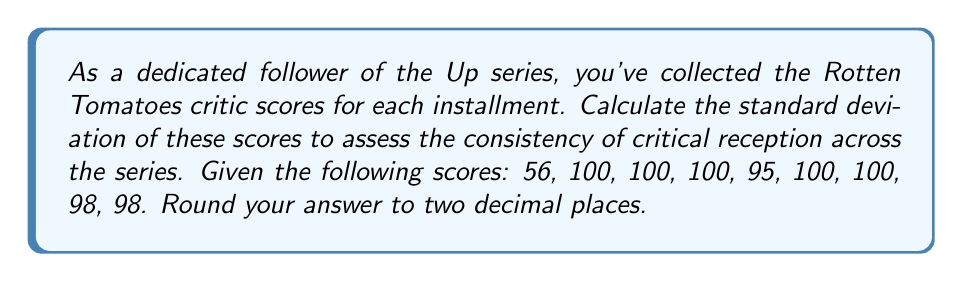Show me your answer to this math problem. To calculate the standard deviation, we'll follow these steps:

1. Calculate the mean ($\mu$) of the scores:
   $$\mu = \frac{56 + 100 + 100 + 100 + 95 + 100 + 100 + 98 + 98}{9} = 94.11$$

2. Calculate the squared differences from the mean:
   $$(56 - 94.11)^2 = 1454.37$$
   $$(100 - 94.11)^2 = 34.61$$
   $$(95 - 94.11)^2 = 0.79$$
   $$(98 - 94.11)^2 = 15.13$$

3. Sum the squared differences:
   $$1454.37 + (34.61 \times 5) + 0.79 + (15.13 \times 2) = 1654.72$$

4. Calculate the variance by dividing the sum by $(n-1) = 8$:
   $$\text{Variance} = \frac{1654.72}{8} = 206.84$$

5. Take the square root of the variance to get the standard deviation:
   $$\text{Standard Deviation} = \sqrt{206.84} = 14.38$$

6. Round to two decimal places: 14.38
Answer: $14.38$ 